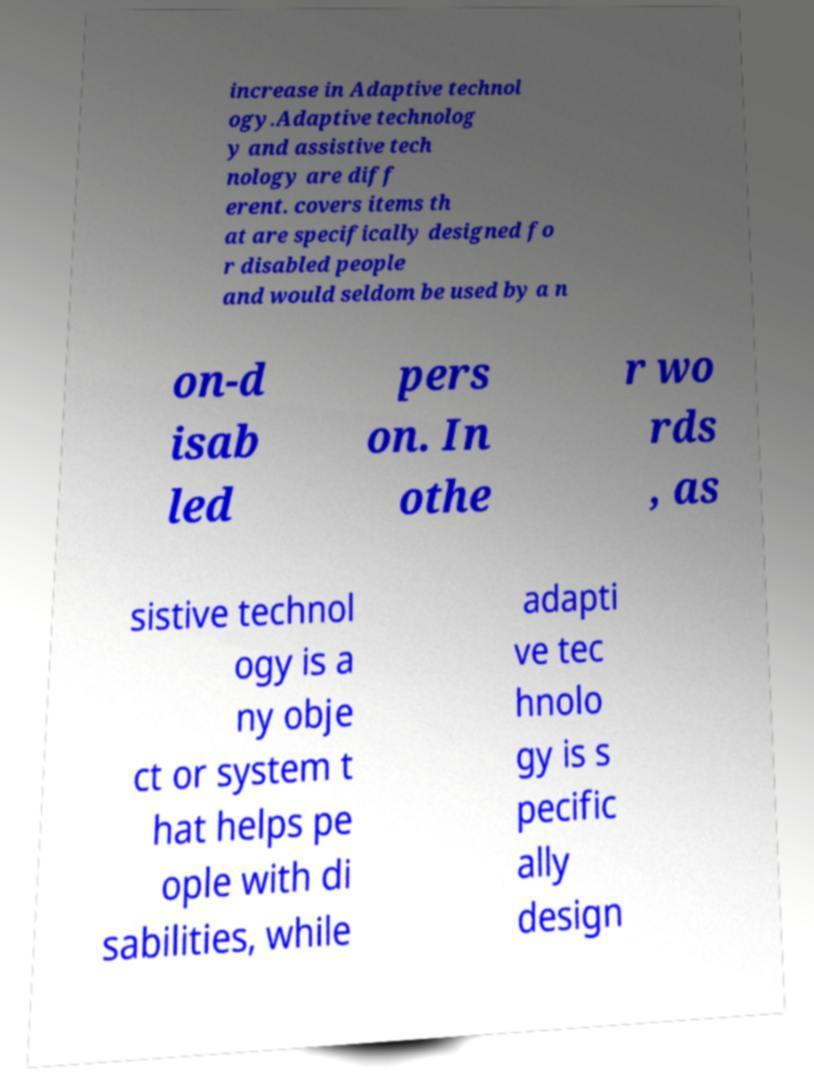I need the written content from this picture converted into text. Can you do that? increase in Adaptive technol ogy.Adaptive technolog y and assistive tech nology are diff erent. covers items th at are specifically designed fo r disabled people and would seldom be used by a n on-d isab led pers on. In othe r wo rds , as sistive technol ogy is a ny obje ct or system t hat helps pe ople with di sabilities, while adapti ve tec hnolo gy is s pecific ally design 